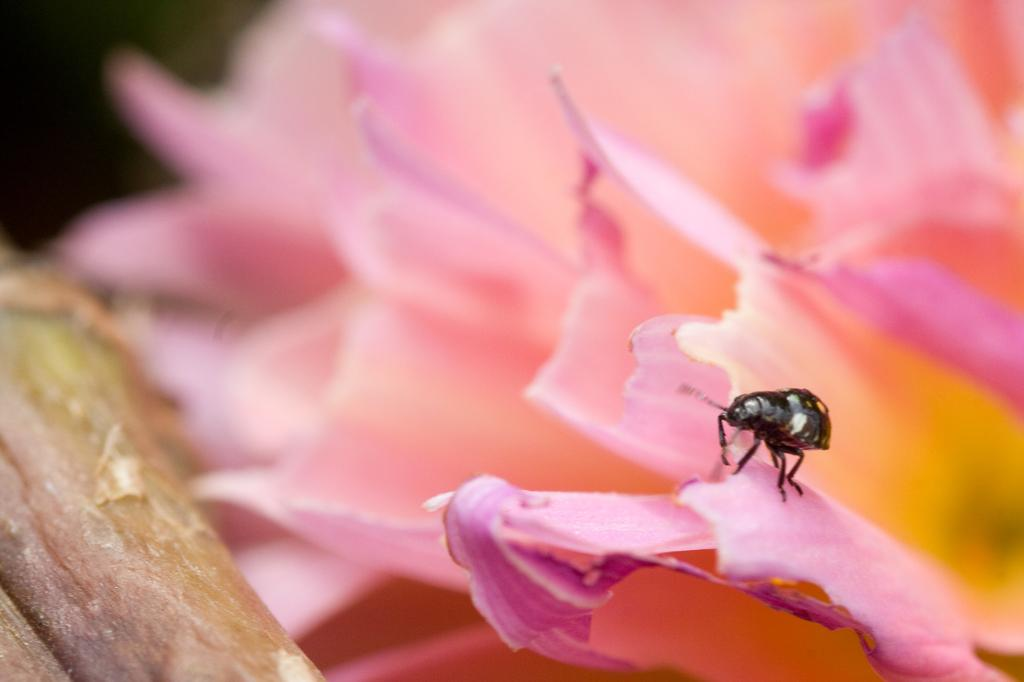What type of living organisms can be seen in the image? The image contains flowers and an insect. Where is the insect located in the image? The insect is in the center of the image. Can you describe any part of the flowers in the image? There may be a stem on the left side of the image. How would you describe the background of the image? The background of the image is blurred. What degree of difficulty is the machine set to in the image? There is no machine present in the image, so it is not possible to determine the degree of difficulty. 